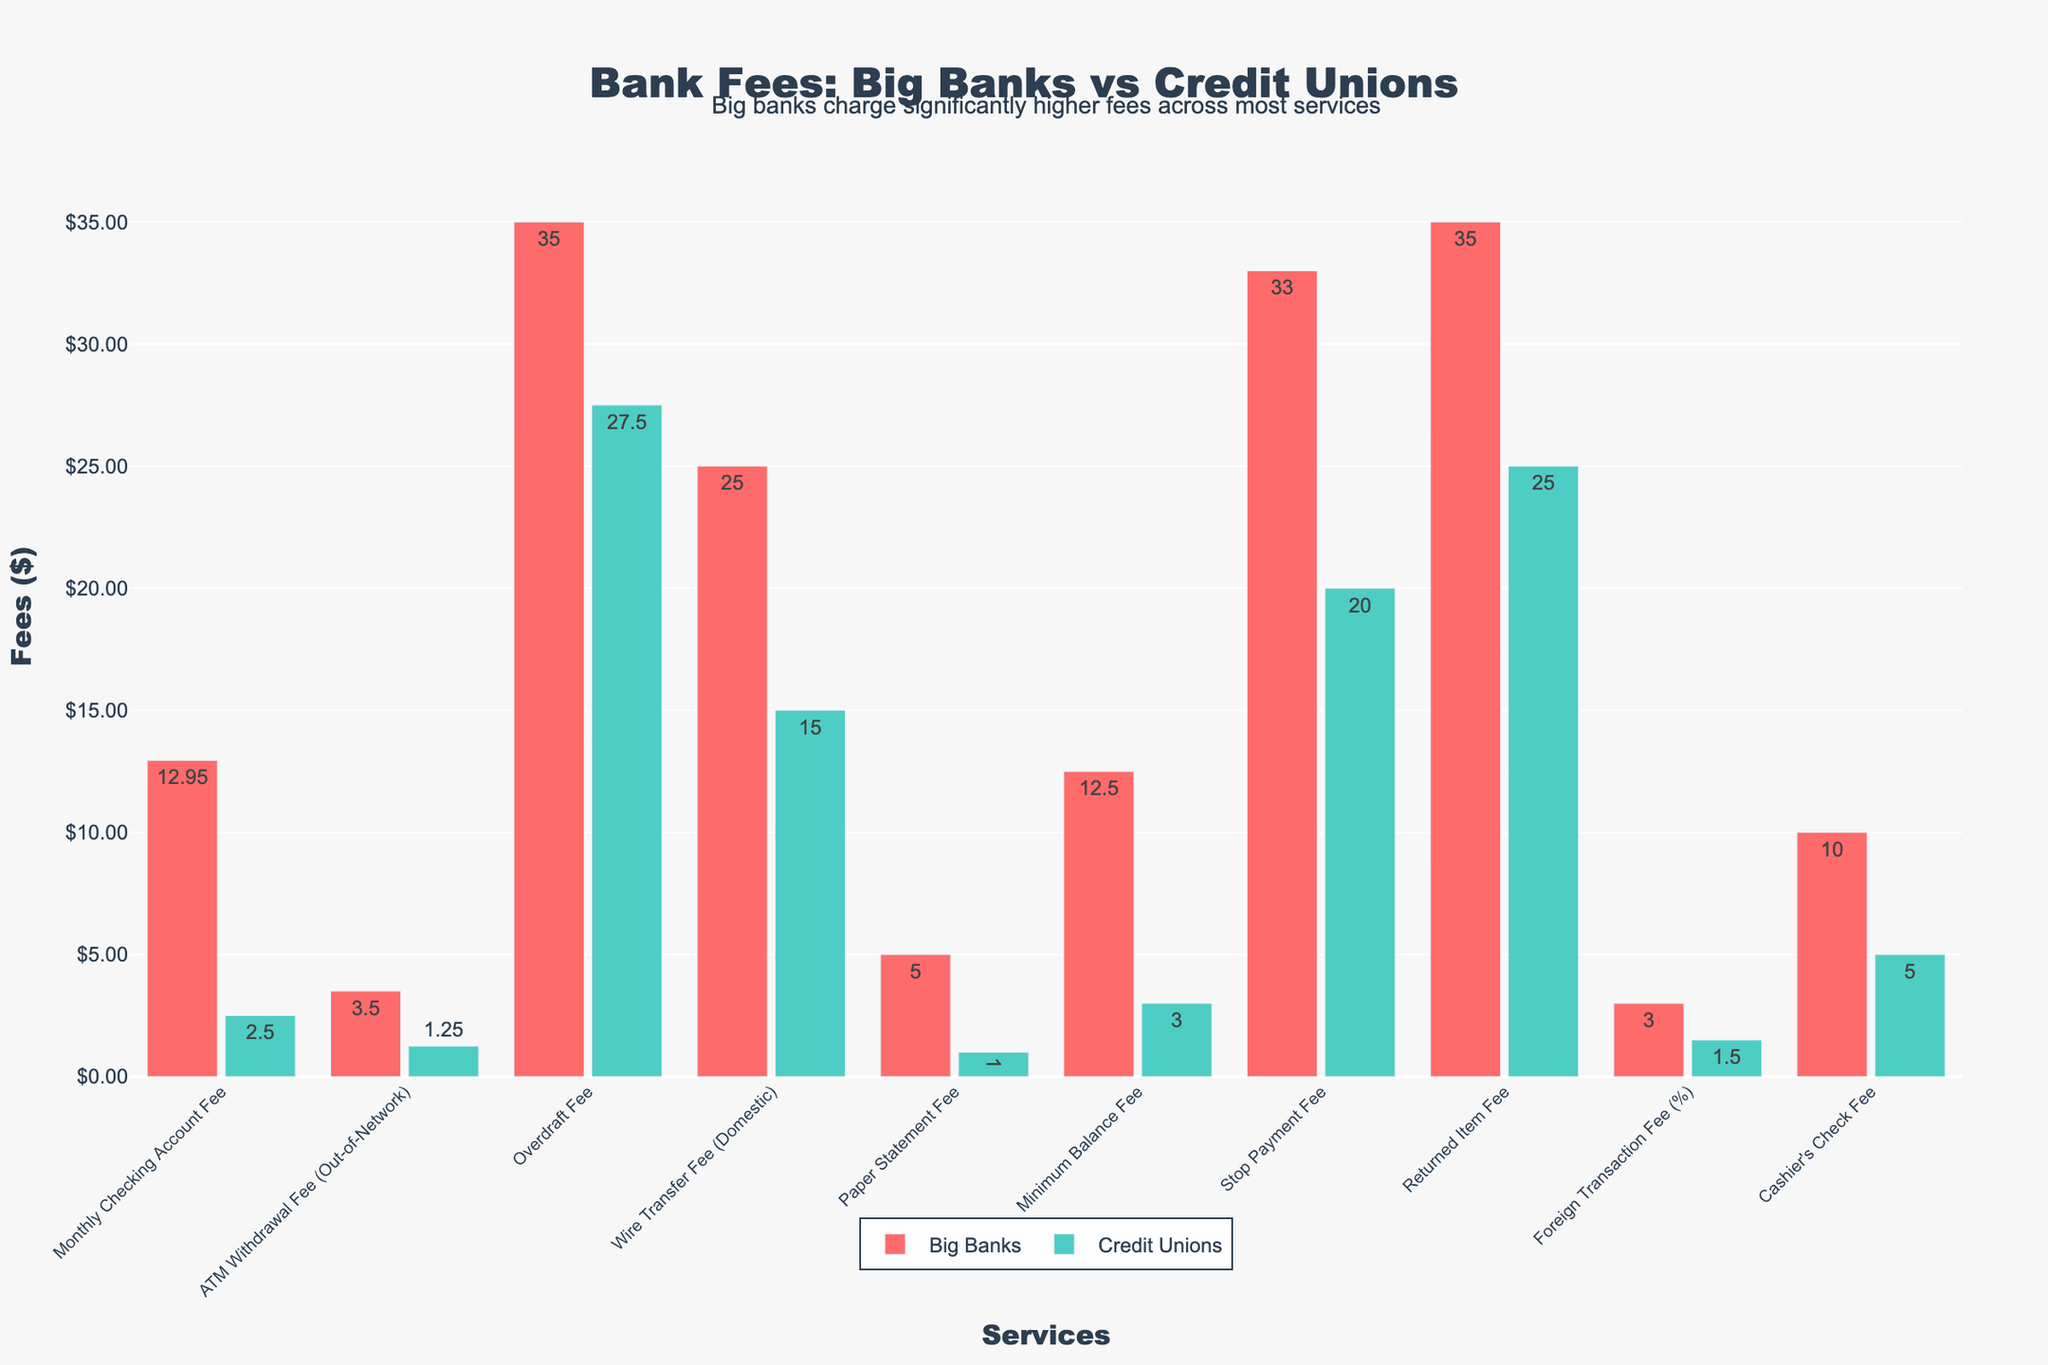What is the difference in the monthly checking account fee between big banks and credit unions? The monthly checking account fee for big banks is $12.95, and for credit unions, it is $2.50. The difference is calculated as $12.95 - $2.50.
Answer: $10.45 Which service has the largest fee difference between big banks and credit unions? To find the service with the largest fee difference, we need to subtract the fees of credit unions from those of big banks for each service and see which difference is the largest. The differences are:
- Monthly Checking Account Fee: $12.95 - $2.50 = $10.45
- ATM Withdrawal Fee (Out-of-Network): $3.50 - $1.25 = $2.25
- Overdraft Fee: $35.00 - $27.50 = $7.50
- Wire Transfer Fee (Domestic): $25.00 - $15.00 = $10.00
- Paper Statement Fee: $5.00 - $1.00 = $4.00
- Minimum Balance Fee: $12.50 - $3.00 = $9.50
- Stop Payment Fee: $33.00 - $20.00 = $13.00
- Returned Item Fee: $35.00 - $25.00 = $10.00
- Foreign Transaction Fee (%): 3.00% - 1.50% = 1.50%
- Cashier's Check Fee: $10.00 - $5.00 = $5.00
The largest difference is $13.00 for the Stop Payment Fee.
Answer: Stop Payment Fee Which service has the smallest fee difference between big banks and credit unions? To find the service with the smallest fee difference, we need to subtract the fees of credit unions from those of big banks for each service and see which difference is the smallest. The differences are:
- Monthly Checking Account Fee: $12.95 - $2.50 = $10.45
- ATM Withdrawal Fee (Out-of-Network): $3.50 - $1.25 = $2.25
- Overdraft Fee: $35.00 - $27.50 = $7.50
- Wire Transfer Fee (Domestic): $25.00 - $15.00 = $10.00
- Paper Statement Fee: $5.00 - $1.00 = $4.00
- Minimum Balance Fee: $12.50 - $3.00 = $9.50
- Stop Payment Fee: $33.00 - $20.00 = $13.00
- Returned Item Fee: $35.00 - $25.00 = $10.00
- Foreign Transaction Fee (%): 3.00% - 1.50% = 1.50%
- Cashier's Check Fee: $10.00 - $5.00 = $5.00
The smallest difference is $1.50 for the Foreign Transaction Fee.
Answer: Foreign Transaction Fee What is the combined fee for a stop payment and a returned item at big banks? To find the combined fee for a stop payment and a returned item at big banks, add the fee for a stop payment ($33.00) to the fee for a returned item ($35.00).
Answer: $68.00 By how much is the overdraft fee at big banks higher than that at credit unions? The overdraft fee for big banks is $35.00, and for credit unions, it is $27.50. The difference is calculated as $35.00 - $27.50.
Answer: $7.50 Which fee is the highest for credit unions, and what is its value? To find the highest fee for credit unions, look at the values listed under credit unions' fees. The highest value among them is $27.50 for the overdraft fee.
Answer: Overdraft Fee, $27.50 What is the visual difference in the height of bars representing wire transfer fees between big banks and credit unions? The wire transfer fee at big banks has a taller bar than at credit unions. This indicates that the fee is $25.00 for big banks and $15.00 for credit unions. Visually, the height of the big banks' bar is significantly greater compared to that of credit unions.
Answer: Higher for big banks 